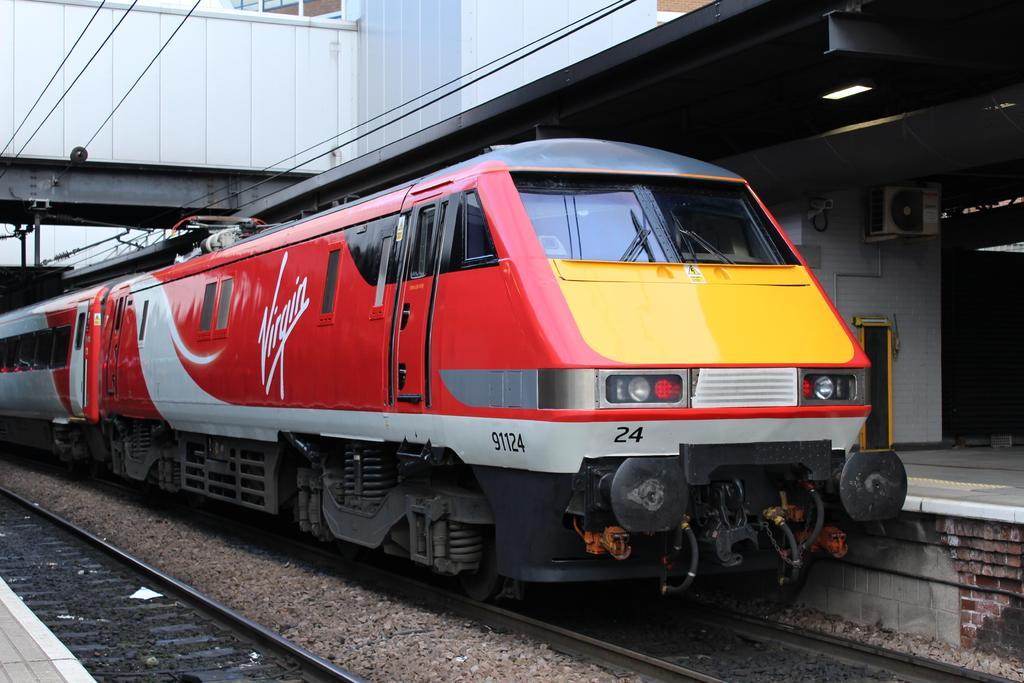Please provide a concise description of this image. In this picture, we can see a train, rail track, platform, wall, with doors, and roof with lights, we can see wires, and partially covered windows. 